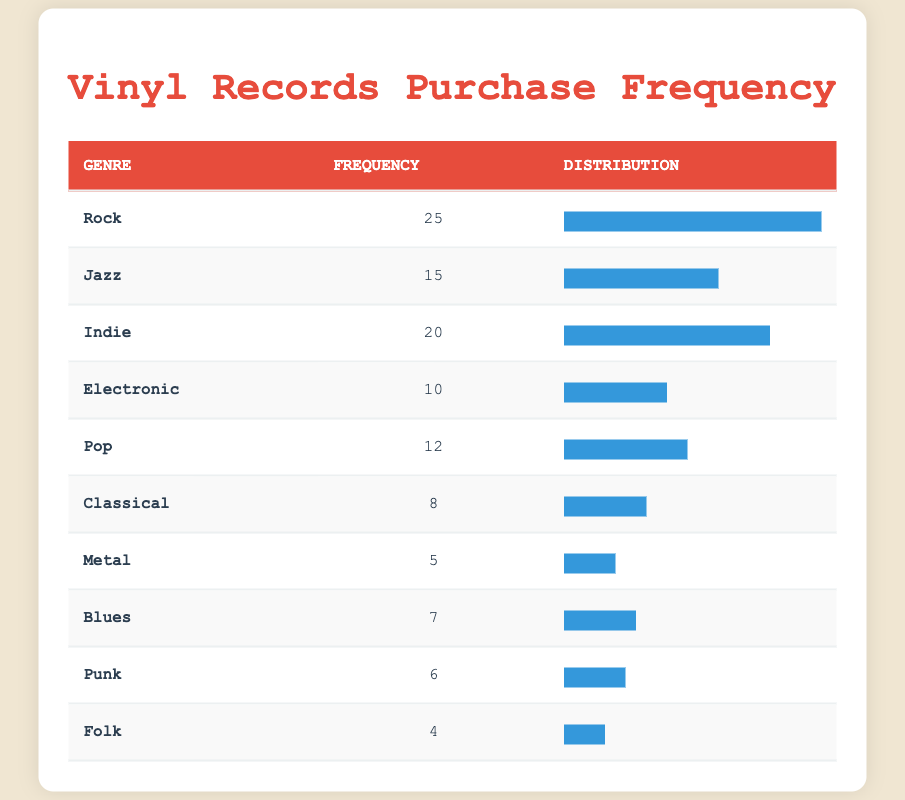What is the frequency of Vinyl records purchased in the Rock genre? The frequency of vinyl records purchased in the Rock genre is provided directly in the table. It states that the frequency for Rock is 25.
Answer: 25 How many genres had a frequency of 10 or less? The table lists all the genres and their corresponding frequencies. By examining the table, the genres with frequencies of 10 or less are Electronic (10), Metal (5), Blues (7), Punk (6), and Folk (4). This totals to five genres.
Answer: 5 Which genre had the second highest frequency of purchases? To find the second highest frequency, I look at the frequencies listed in the table. The highest is Rock (25), and the second highest is Indie (20).
Answer: Indie What is the total frequency of vinyl records purchased across all genres? To find the total frequency, I sum the frequencies of all genres listed in the table: 25 (Rock) + 15 (Jazz) + 20 (Indie) + 10 (Electronic) + 12 (Pop) + 8 (Classical) + 5 (Metal) + 7 (Blues) + 6 (Punk) + 4 (Folk) = 112.
Answer: 112 Is it true that more Jazz records were purchased than Pop records? Looking at the frequencies in the table, Jazz records have a frequency of 15, while Pop records have a frequency of 12. Therefore, it is true that more Jazz records were purchased than Pop records.
Answer: Yes What is the average frequency of vinyl records purchased across all genres? To calculate the average frequency, I first find the total frequency (112 from the previous question) and divide it by the number of genres (10): 112 / 10 = 11.2.
Answer: 11.2 How many more Rock records were purchased compared to Classical records? From the table, the frequency of Rock records is 25, whereas Classical records have a frequency of 8. The difference is calculated by subtracting Classical from Rock: 25 - 8 = 17.
Answer: 17 Which genre has the least number of records purchased? By reviewing the table, I can see that the genre with the least number of records purchased is Folk, which has a frequency of 4.
Answer: Folk 